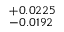<formula> <loc_0><loc_0><loc_500><loc_500>^ { + 0 . 0 2 2 5 } _ { - 0 . 0 1 9 2 }</formula> 